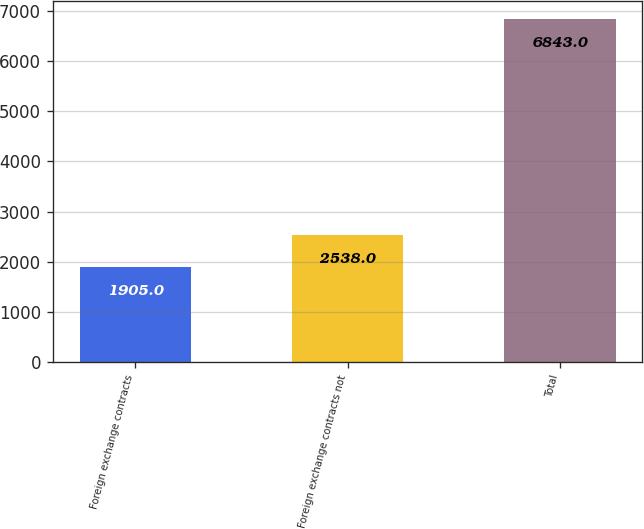Convert chart to OTSL. <chart><loc_0><loc_0><loc_500><loc_500><bar_chart><fcel>Foreign exchange contracts<fcel>Foreign exchange contracts not<fcel>Total<nl><fcel>1905<fcel>2538<fcel>6843<nl></chart> 